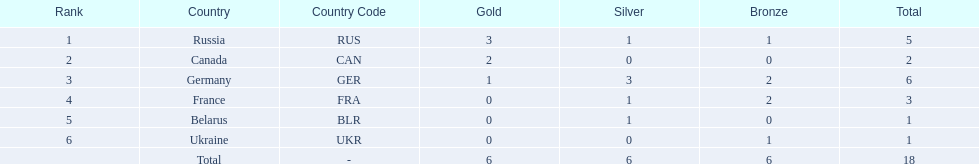Help me parse the entirety of this table. {'header': ['Rank', 'Country', 'Country Code', 'Gold', 'Silver', 'Bronze', 'Total'], 'rows': [['1', 'Russia', 'RUS', '3', '1', '1', '5'], ['2', 'Canada', 'CAN', '2', '0', '0', '2'], ['3', 'Germany', 'GER', '1', '3', '2', '6'], ['4', 'France', 'FRA', '0', '1', '2', '3'], ['5', 'Belarus', 'BLR', '0', '1', '0', '1'], ['6', 'Ukraine', 'UKR', '0', '0', '1', '1'], ['', 'Total', '-', '6', '6', '6', '18']]} Which countries had one or more gold medals? Russia (RUS), Canada (CAN), Germany (GER). Of these countries, which had at least one silver medal? Russia (RUS), Germany (GER). Of the remaining countries, who had more medals overall? Germany (GER). 